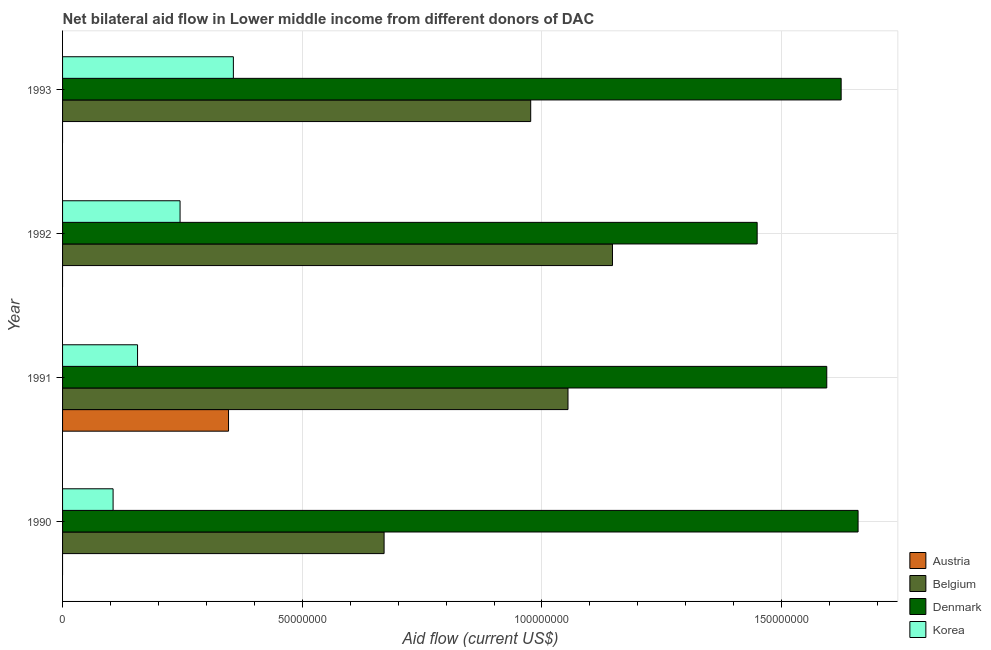How many different coloured bars are there?
Your response must be concise. 4. What is the label of the 4th group of bars from the top?
Keep it short and to the point. 1990. In how many cases, is the number of bars for a given year not equal to the number of legend labels?
Your response must be concise. 3. What is the amount of aid given by austria in 1990?
Make the answer very short. 0. Across all years, what is the maximum amount of aid given by denmark?
Your answer should be very brief. 1.66e+08. Across all years, what is the minimum amount of aid given by korea?
Offer a very short reply. 1.05e+07. What is the total amount of aid given by belgium in the graph?
Offer a terse response. 3.85e+08. What is the difference between the amount of aid given by belgium in 1991 and that in 1993?
Your answer should be compact. 7.78e+06. What is the difference between the amount of aid given by korea in 1990 and the amount of aid given by austria in 1993?
Your response must be concise. 1.05e+07. What is the average amount of aid given by denmark per year?
Offer a very short reply. 1.58e+08. In the year 1993, what is the difference between the amount of aid given by belgium and amount of aid given by denmark?
Your answer should be very brief. -6.48e+07. What is the ratio of the amount of aid given by korea in 1991 to that in 1993?
Provide a short and direct response. 0.44. Is the amount of aid given by denmark in 1990 less than that in 1991?
Your answer should be very brief. No. Is the difference between the amount of aid given by denmark in 1991 and 1992 greater than the difference between the amount of aid given by korea in 1991 and 1992?
Give a very brief answer. Yes. What is the difference between the highest and the second highest amount of aid given by korea?
Your answer should be compact. 1.11e+07. What is the difference between the highest and the lowest amount of aid given by denmark?
Offer a terse response. 2.10e+07. In how many years, is the amount of aid given by denmark greater than the average amount of aid given by denmark taken over all years?
Your answer should be compact. 3. Is the sum of the amount of aid given by denmark in 1992 and 1993 greater than the maximum amount of aid given by austria across all years?
Your answer should be compact. Yes. Is it the case that in every year, the sum of the amount of aid given by korea and amount of aid given by belgium is greater than the sum of amount of aid given by denmark and amount of aid given by austria?
Offer a very short reply. Yes. How many bars are there?
Provide a short and direct response. 13. Are all the bars in the graph horizontal?
Give a very brief answer. Yes. Are the values on the major ticks of X-axis written in scientific E-notation?
Ensure brevity in your answer.  No. Where does the legend appear in the graph?
Keep it short and to the point. Bottom right. What is the title of the graph?
Provide a succinct answer. Net bilateral aid flow in Lower middle income from different donors of DAC. Does "Minerals" appear as one of the legend labels in the graph?
Provide a short and direct response. No. What is the Aid flow (current US$) in Austria in 1990?
Your answer should be very brief. 0. What is the Aid flow (current US$) of Belgium in 1990?
Your answer should be compact. 6.71e+07. What is the Aid flow (current US$) in Denmark in 1990?
Make the answer very short. 1.66e+08. What is the Aid flow (current US$) in Korea in 1990?
Your answer should be very brief. 1.05e+07. What is the Aid flow (current US$) of Austria in 1991?
Give a very brief answer. 3.46e+07. What is the Aid flow (current US$) in Belgium in 1991?
Keep it short and to the point. 1.05e+08. What is the Aid flow (current US$) in Denmark in 1991?
Keep it short and to the point. 1.59e+08. What is the Aid flow (current US$) of Korea in 1991?
Your answer should be very brief. 1.56e+07. What is the Aid flow (current US$) of Austria in 1992?
Your answer should be very brief. 0. What is the Aid flow (current US$) of Belgium in 1992?
Your answer should be compact. 1.15e+08. What is the Aid flow (current US$) in Denmark in 1992?
Offer a very short reply. 1.45e+08. What is the Aid flow (current US$) in Korea in 1992?
Ensure brevity in your answer.  2.45e+07. What is the Aid flow (current US$) in Austria in 1993?
Ensure brevity in your answer.  0. What is the Aid flow (current US$) in Belgium in 1993?
Ensure brevity in your answer.  9.76e+07. What is the Aid flow (current US$) of Denmark in 1993?
Keep it short and to the point. 1.62e+08. What is the Aid flow (current US$) in Korea in 1993?
Provide a succinct answer. 3.56e+07. Across all years, what is the maximum Aid flow (current US$) in Austria?
Your response must be concise. 3.46e+07. Across all years, what is the maximum Aid flow (current US$) in Belgium?
Offer a very short reply. 1.15e+08. Across all years, what is the maximum Aid flow (current US$) in Denmark?
Provide a short and direct response. 1.66e+08. Across all years, what is the maximum Aid flow (current US$) of Korea?
Provide a succinct answer. 3.56e+07. Across all years, what is the minimum Aid flow (current US$) in Austria?
Offer a very short reply. 0. Across all years, what is the minimum Aid flow (current US$) of Belgium?
Provide a succinct answer. 6.71e+07. Across all years, what is the minimum Aid flow (current US$) in Denmark?
Your answer should be compact. 1.45e+08. Across all years, what is the minimum Aid flow (current US$) in Korea?
Ensure brevity in your answer.  1.05e+07. What is the total Aid flow (current US$) in Austria in the graph?
Provide a succinct answer. 3.46e+07. What is the total Aid flow (current US$) in Belgium in the graph?
Provide a succinct answer. 3.85e+08. What is the total Aid flow (current US$) of Denmark in the graph?
Offer a very short reply. 6.33e+08. What is the total Aid flow (current US$) of Korea in the graph?
Make the answer very short. 8.63e+07. What is the difference between the Aid flow (current US$) of Belgium in 1990 and that in 1991?
Offer a terse response. -3.84e+07. What is the difference between the Aid flow (current US$) in Denmark in 1990 and that in 1991?
Make the answer very short. 6.53e+06. What is the difference between the Aid flow (current US$) in Korea in 1990 and that in 1991?
Provide a short and direct response. -5.10e+06. What is the difference between the Aid flow (current US$) in Belgium in 1990 and that in 1992?
Offer a very short reply. -4.76e+07. What is the difference between the Aid flow (current US$) of Denmark in 1990 and that in 1992?
Offer a terse response. 2.10e+07. What is the difference between the Aid flow (current US$) of Korea in 1990 and that in 1992?
Give a very brief answer. -1.40e+07. What is the difference between the Aid flow (current US$) of Belgium in 1990 and that in 1993?
Give a very brief answer. -3.06e+07. What is the difference between the Aid flow (current US$) of Denmark in 1990 and that in 1993?
Provide a succinct answer. 3.53e+06. What is the difference between the Aid flow (current US$) of Korea in 1990 and that in 1993?
Your answer should be very brief. -2.51e+07. What is the difference between the Aid flow (current US$) of Belgium in 1991 and that in 1992?
Provide a succinct answer. -9.28e+06. What is the difference between the Aid flow (current US$) in Denmark in 1991 and that in 1992?
Offer a very short reply. 1.45e+07. What is the difference between the Aid flow (current US$) of Korea in 1991 and that in 1992?
Offer a terse response. -8.87e+06. What is the difference between the Aid flow (current US$) in Belgium in 1991 and that in 1993?
Ensure brevity in your answer.  7.78e+06. What is the difference between the Aid flow (current US$) of Denmark in 1991 and that in 1993?
Offer a very short reply. -3.00e+06. What is the difference between the Aid flow (current US$) in Korea in 1991 and that in 1993?
Offer a terse response. -2.00e+07. What is the difference between the Aid flow (current US$) of Belgium in 1992 and that in 1993?
Offer a terse response. 1.71e+07. What is the difference between the Aid flow (current US$) of Denmark in 1992 and that in 1993?
Offer a very short reply. -1.75e+07. What is the difference between the Aid flow (current US$) of Korea in 1992 and that in 1993?
Ensure brevity in your answer.  -1.11e+07. What is the difference between the Aid flow (current US$) of Belgium in 1990 and the Aid flow (current US$) of Denmark in 1991?
Provide a succinct answer. -9.23e+07. What is the difference between the Aid flow (current US$) of Belgium in 1990 and the Aid flow (current US$) of Korea in 1991?
Make the answer very short. 5.14e+07. What is the difference between the Aid flow (current US$) of Denmark in 1990 and the Aid flow (current US$) of Korea in 1991?
Your answer should be very brief. 1.50e+08. What is the difference between the Aid flow (current US$) in Belgium in 1990 and the Aid flow (current US$) in Denmark in 1992?
Provide a short and direct response. -7.78e+07. What is the difference between the Aid flow (current US$) in Belgium in 1990 and the Aid flow (current US$) in Korea in 1992?
Give a very brief answer. 4.26e+07. What is the difference between the Aid flow (current US$) in Denmark in 1990 and the Aid flow (current US$) in Korea in 1992?
Keep it short and to the point. 1.41e+08. What is the difference between the Aid flow (current US$) in Belgium in 1990 and the Aid flow (current US$) in Denmark in 1993?
Make the answer very short. -9.53e+07. What is the difference between the Aid flow (current US$) of Belgium in 1990 and the Aid flow (current US$) of Korea in 1993?
Provide a succinct answer. 3.14e+07. What is the difference between the Aid flow (current US$) in Denmark in 1990 and the Aid flow (current US$) in Korea in 1993?
Give a very brief answer. 1.30e+08. What is the difference between the Aid flow (current US$) in Austria in 1991 and the Aid flow (current US$) in Belgium in 1992?
Offer a very short reply. -8.01e+07. What is the difference between the Aid flow (current US$) of Austria in 1991 and the Aid flow (current US$) of Denmark in 1992?
Give a very brief answer. -1.10e+08. What is the difference between the Aid flow (current US$) of Austria in 1991 and the Aid flow (current US$) of Korea in 1992?
Offer a terse response. 1.01e+07. What is the difference between the Aid flow (current US$) in Belgium in 1991 and the Aid flow (current US$) in Denmark in 1992?
Your answer should be compact. -3.95e+07. What is the difference between the Aid flow (current US$) of Belgium in 1991 and the Aid flow (current US$) of Korea in 1992?
Give a very brief answer. 8.09e+07. What is the difference between the Aid flow (current US$) in Denmark in 1991 and the Aid flow (current US$) in Korea in 1992?
Offer a terse response. 1.35e+08. What is the difference between the Aid flow (current US$) of Austria in 1991 and the Aid flow (current US$) of Belgium in 1993?
Offer a terse response. -6.30e+07. What is the difference between the Aid flow (current US$) in Austria in 1991 and the Aid flow (current US$) in Denmark in 1993?
Offer a very short reply. -1.28e+08. What is the difference between the Aid flow (current US$) in Austria in 1991 and the Aid flow (current US$) in Korea in 1993?
Offer a terse response. -1.01e+06. What is the difference between the Aid flow (current US$) in Belgium in 1991 and the Aid flow (current US$) in Denmark in 1993?
Ensure brevity in your answer.  -5.70e+07. What is the difference between the Aid flow (current US$) in Belgium in 1991 and the Aid flow (current US$) in Korea in 1993?
Keep it short and to the point. 6.98e+07. What is the difference between the Aid flow (current US$) in Denmark in 1991 and the Aid flow (current US$) in Korea in 1993?
Your answer should be very brief. 1.24e+08. What is the difference between the Aid flow (current US$) in Belgium in 1992 and the Aid flow (current US$) in Denmark in 1993?
Give a very brief answer. -4.77e+07. What is the difference between the Aid flow (current US$) of Belgium in 1992 and the Aid flow (current US$) of Korea in 1993?
Make the answer very short. 7.91e+07. What is the difference between the Aid flow (current US$) in Denmark in 1992 and the Aid flow (current US$) in Korea in 1993?
Your answer should be compact. 1.09e+08. What is the average Aid flow (current US$) in Austria per year?
Provide a short and direct response. 8.66e+06. What is the average Aid flow (current US$) in Belgium per year?
Make the answer very short. 9.62e+07. What is the average Aid flow (current US$) in Denmark per year?
Give a very brief answer. 1.58e+08. What is the average Aid flow (current US$) of Korea per year?
Provide a succinct answer. 2.16e+07. In the year 1990, what is the difference between the Aid flow (current US$) in Belgium and Aid flow (current US$) in Denmark?
Ensure brevity in your answer.  -9.89e+07. In the year 1990, what is the difference between the Aid flow (current US$) in Belgium and Aid flow (current US$) in Korea?
Provide a short and direct response. 5.65e+07. In the year 1990, what is the difference between the Aid flow (current US$) in Denmark and Aid flow (current US$) in Korea?
Make the answer very short. 1.55e+08. In the year 1991, what is the difference between the Aid flow (current US$) of Austria and Aid flow (current US$) of Belgium?
Provide a short and direct response. -7.08e+07. In the year 1991, what is the difference between the Aid flow (current US$) of Austria and Aid flow (current US$) of Denmark?
Provide a succinct answer. -1.25e+08. In the year 1991, what is the difference between the Aid flow (current US$) of Austria and Aid flow (current US$) of Korea?
Offer a terse response. 1.90e+07. In the year 1991, what is the difference between the Aid flow (current US$) in Belgium and Aid flow (current US$) in Denmark?
Your answer should be very brief. -5.40e+07. In the year 1991, what is the difference between the Aid flow (current US$) of Belgium and Aid flow (current US$) of Korea?
Ensure brevity in your answer.  8.98e+07. In the year 1991, what is the difference between the Aid flow (current US$) of Denmark and Aid flow (current US$) of Korea?
Your answer should be very brief. 1.44e+08. In the year 1992, what is the difference between the Aid flow (current US$) in Belgium and Aid flow (current US$) in Denmark?
Provide a succinct answer. -3.02e+07. In the year 1992, what is the difference between the Aid flow (current US$) in Belgium and Aid flow (current US$) in Korea?
Offer a very short reply. 9.02e+07. In the year 1992, what is the difference between the Aid flow (current US$) in Denmark and Aid flow (current US$) in Korea?
Make the answer very short. 1.20e+08. In the year 1993, what is the difference between the Aid flow (current US$) in Belgium and Aid flow (current US$) in Denmark?
Give a very brief answer. -6.48e+07. In the year 1993, what is the difference between the Aid flow (current US$) of Belgium and Aid flow (current US$) of Korea?
Your answer should be very brief. 6.20e+07. In the year 1993, what is the difference between the Aid flow (current US$) of Denmark and Aid flow (current US$) of Korea?
Provide a short and direct response. 1.27e+08. What is the ratio of the Aid flow (current US$) in Belgium in 1990 to that in 1991?
Offer a terse response. 0.64. What is the ratio of the Aid flow (current US$) of Denmark in 1990 to that in 1991?
Give a very brief answer. 1.04. What is the ratio of the Aid flow (current US$) in Korea in 1990 to that in 1991?
Ensure brevity in your answer.  0.67. What is the ratio of the Aid flow (current US$) of Belgium in 1990 to that in 1992?
Make the answer very short. 0.58. What is the ratio of the Aid flow (current US$) of Denmark in 1990 to that in 1992?
Ensure brevity in your answer.  1.15. What is the ratio of the Aid flow (current US$) of Korea in 1990 to that in 1992?
Provide a succinct answer. 0.43. What is the ratio of the Aid flow (current US$) in Belgium in 1990 to that in 1993?
Ensure brevity in your answer.  0.69. What is the ratio of the Aid flow (current US$) of Denmark in 1990 to that in 1993?
Give a very brief answer. 1.02. What is the ratio of the Aid flow (current US$) of Korea in 1990 to that in 1993?
Keep it short and to the point. 0.3. What is the ratio of the Aid flow (current US$) in Belgium in 1991 to that in 1992?
Keep it short and to the point. 0.92. What is the ratio of the Aid flow (current US$) in Denmark in 1991 to that in 1992?
Your answer should be very brief. 1.1. What is the ratio of the Aid flow (current US$) in Korea in 1991 to that in 1992?
Give a very brief answer. 0.64. What is the ratio of the Aid flow (current US$) of Belgium in 1991 to that in 1993?
Provide a short and direct response. 1.08. What is the ratio of the Aid flow (current US$) of Denmark in 1991 to that in 1993?
Offer a terse response. 0.98. What is the ratio of the Aid flow (current US$) of Korea in 1991 to that in 1993?
Make the answer very short. 0.44. What is the ratio of the Aid flow (current US$) in Belgium in 1992 to that in 1993?
Your response must be concise. 1.17. What is the ratio of the Aid flow (current US$) of Denmark in 1992 to that in 1993?
Keep it short and to the point. 0.89. What is the ratio of the Aid flow (current US$) of Korea in 1992 to that in 1993?
Keep it short and to the point. 0.69. What is the difference between the highest and the second highest Aid flow (current US$) of Belgium?
Provide a succinct answer. 9.28e+06. What is the difference between the highest and the second highest Aid flow (current US$) in Denmark?
Provide a short and direct response. 3.53e+06. What is the difference between the highest and the second highest Aid flow (current US$) of Korea?
Your answer should be compact. 1.11e+07. What is the difference between the highest and the lowest Aid flow (current US$) of Austria?
Provide a succinct answer. 3.46e+07. What is the difference between the highest and the lowest Aid flow (current US$) in Belgium?
Your response must be concise. 4.76e+07. What is the difference between the highest and the lowest Aid flow (current US$) of Denmark?
Offer a terse response. 2.10e+07. What is the difference between the highest and the lowest Aid flow (current US$) of Korea?
Your answer should be very brief. 2.51e+07. 